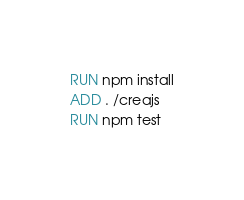Convert code to text. <code><loc_0><loc_0><loc_500><loc_500><_Dockerfile_>RUN npm install
ADD . /creajs
RUN npm test
</code> 